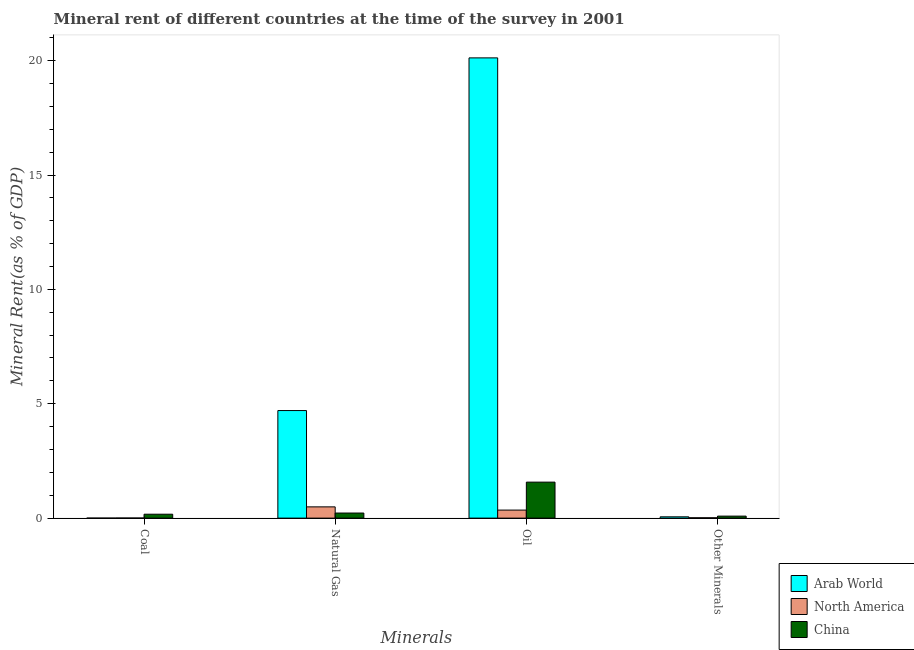How many different coloured bars are there?
Give a very brief answer. 3. How many groups of bars are there?
Your response must be concise. 4. Are the number of bars on each tick of the X-axis equal?
Ensure brevity in your answer.  Yes. How many bars are there on the 4th tick from the left?
Keep it short and to the point. 3. How many bars are there on the 4th tick from the right?
Your answer should be very brief. 3. What is the label of the 2nd group of bars from the left?
Offer a very short reply. Natural Gas. What is the  rent of other minerals in Arab World?
Provide a short and direct response. 0.06. Across all countries, what is the maximum natural gas rent?
Provide a short and direct response. 4.7. Across all countries, what is the minimum  rent of other minerals?
Offer a terse response. 0.01. In which country was the oil rent maximum?
Make the answer very short. Arab World. In which country was the coal rent minimum?
Give a very brief answer. Arab World. What is the total coal rent in the graph?
Provide a short and direct response. 0.17. What is the difference between the  rent of other minerals in North America and that in China?
Provide a succinct answer. -0.07. What is the difference between the natural gas rent in Arab World and the coal rent in North America?
Your answer should be very brief. 4.7. What is the average natural gas rent per country?
Provide a succinct answer. 1.81. What is the difference between the natural gas rent and oil rent in China?
Keep it short and to the point. -1.35. In how many countries, is the oil rent greater than 9 %?
Keep it short and to the point. 1. What is the ratio of the oil rent in China to that in North America?
Make the answer very short. 4.48. Is the  rent of other minerals in China less than that in North America?
Provide a succinct answer. No. What is the difference between the highest and the second highest natural gas rent?
Your answer should be compact. 4.21. What is the difference between the highest and the lowest  rent of other minerals?
Make the answer very short. 0.07. In how many countries, is the oil rent greater than the average oil rent taken over all countries?
Provide a short and direct response. 1. What does the 2nd bar from the left in Coal represents?
Make the answer very short. North America. What does the 3rd bar from the right in Oil represents?
Provide a succinct answer. Arab World. Is it the case that in every country, the sum of the coal rent and natural gas rent is greater than the oil rent?
Your response must be concise. No. What is the difference between two consecutive major ticks on the Y-axis?
Make the answer very short. 5. Does the graph contain grids?
Your answer should be compact. No. How many legend labels are there?
Your answer should be very brief. 3. How are the legend labels stacked?
Offer a very short reply. Vertical. What is the title of the graph?
Give a very brief answer. Mineral rent of different countries at the time of the survey in 2001. What is the label or title of the X-axis?
Make the answer very short. Minerals. What is the label or title of the Y-axis?
Make the answer very short. Mineral Rent(as % of GDP). What is the Mineral Rent(as % of GDP) of Arab World in Coal?
Your answer should be compact. 1.52442917434249e-7. What is the Mineral Rent(as % of GDP) in North America in Coal?
Your answer should be very brief. 0. What is the Mineral Rent(as % of GDP) in China in Coal?
Ensure brevity in your answer.  0.17. What is the Mineral Rent(as % of GDP) of Arab World in Natural Gas?
Offer a terse response. 4.7. What is the Mineral Rent(as % of GDP) in North America in Natural Gas?
Your answer should be very brief. 0.49. What is the Mineral Rent(as % of GDP) in China in Natural Gas?
Ensure brevity in your answer.  0.22. What is the Mineral Rent(as % of GDP) of Arab World in Oil?
Offer a terse response. 20.12. What is the Mineral Rent(as % of GDP) of North America in Oil?
Offer a terse response. 0.35. What is the Mineral Rent(as % of GDP) of China in Oil?
Provide a short and direct response. 1.57. What is the Mineral Rent(as % of GDP) in Arab World in Other Minerals?
Ensure brevity in your answer.  0.06. What is the Mineral Rent(as % of GDP) of North America in Other Minerals?
Provide a succinct answer. 0.01. What is the Mineral Rent(as % of GDP) in China in Other Minerals?
Keep it short and to the point. 0.09. Across all Minerals, what is the maximum Mineral Rent(as % of GDP) in Arab World?
Ensure brevity in your answer.  20.12. Across all Minerals, what is the maximum Mineral Rent(as % of GDP) in North America?
Your answer should be very brief. 0.49. Across all Minerals, what is the maximum Mineral Rent(as % of GDP) of China?
Your answer should be very brief. 1.57. Across all Minerals, what is the minimum Mineral Rent(as % of GDP) of Arab World?
Offer a terse response. 1.52442917434249e-7. Across all Minerals, what is the minimum Mineral Rent(as % of GDP) in North America?
Your answer should be compact. 0. Across all Minerals, what is the minimum Mineral Rent(as % of GDP) in China?
Your answer should be very brief. 0.09. What is the total Mineral Rent(as % of GDP) of Arab World in the graph?
Provide a short and direct response. 24.88. What is the total Mineral Rent(as % of GDP) in North America in the graph?
Offer a very short reply. 0.86. What is the total Mineral Rent(as % of GDP) in China in the graph?
Offer a very short reply. 2.05. What is the difference between the Mineral Rent(as % of GDP) of Arab World in Coal and that in Natural Gas?
Keep it short and to the point. -4.7. What is the difference between the Mineral Rent(as % of GDP) in North America in Coal and that in Natural Gas?
Keep it short and to the point. -0.49. What is the difference between the Mineral Rent(as % of GDP) in China in Coal and that in Natural Gas?
Provide a succinct answer. -0.05. What is the difference between the Mineral Rent(as % of GDP) of Arab World in Coal and that in Oil?
Your response must be concise. -20.12. What is the difference between the Mineral Rent(as % of GDP) of North America in Coal and that in Oil?
Provide a succinct answer. -0.35. What is the difference between the Mineral Rent(as % of GDP) in China in Coal and that in Oil?
Offer a terse response. -1.4. What is the difference between the Mineral Rent(as % of GDP) in Arab World in Coal and that in Other Minerals?
Make the answer very short. -0.06. What is the difference between the Mineral Rent(as % of GDP) in North America in Coal and that in Other Minerals?
Your answer should be very brief. -0.01. What is the difference between the Mineral Rent(as % of GDP) in China in Coal and that in Other Minerals?
Provide a short and direct response. 0.08. What is the difference between the Mineral Rent(as % of GDP) in Arab World in Natural Gas and that in Oil?
Provide a short and direct response. -15.42. What is the difference between the Mineral Rent(as % of GDP) of North America in Natural Gas and that in Oil?
Keep it short and to the point. 0.14. What is the difference between the Mineral Rent(as % of GDP) of China in Natural Gas and that in Oil?
Offer a very short reply. -1.35. What is the difference between the Mineral Rent(as % of GDP) in Arab World in Natural Gas and that in Other Minerals?
Give a very brief answer. 4.65. What is the difference between the Mineral Rent(as % of GDP) in North America in Natural Gas and that in Other Minerals?
Offer a very short reply. 0.48. What is the difference between the Mineral Rent(as % of GDP) in China in Natural Gas and that in Other Minerals?
Your answer should be compact. 0.14. What is the difference between the Mineral Rent(as % of GDP) of Arab World in Oil and that in Other Minerals?
Your answer should be compact. 20.06. What is the difference between the Mineral Rent(as % of GDP) of North America in Oil and that in Other Minerals?
Provide a succinct answer. 0.34. What is the difference between the Mineral Rent(as % of GDP) in China in Oil and that in Other Minerals?
Provide a succinct answer. 1.49. What is the difference between the Mineral Rent(as % of GDP) of Arab World in Coal and the Mineral Rent(as % of GDP) of North America in Natural Gas?
Your answer should be very brief. -0.49. What is the difference between the Mineral Rent(as % of GDP) in Arab World in Coal and the Mineral Rent(as % of GDP) in China in Natural Gas?
Provide a short and direct response. -0.22. What is the difference between the Mineral Rent(as % of GDP) in North America in Coal and the Mineral Rent(as % of GDP) in China in Natural Gas?
Offer a terse response. -0.22. What is the difference between the Mineral Rent(as % of GDP) in Arab World in Coal and the Mineral Rent(as % of GDP) in North America in Oil?
Make the answer very short. -0.35. What is the difference between the Mineral Rent(as % of GDP) in Arab World in Coal and the Mineral Rent(as % of GDP) in China in Oil?
Ensure brevity in your answer.  -1.57. What is the difference between the Mineral Rent(as % of GDP) in North America in Coal and the Mineral Rent(as % of GDP) in China in Oil?
Give a very brief answer. -1.57. What is the difference between the Mineral Rent(as % of GDP) in Arab World in Coal and the Mineral Rent(as % of GDP) in North America in Other Minerals?
Keep it short and to the point. -0.01. What is the difference between the Mineral Rent(as % of GDP) in Arab World in Coal and the Mineral Rent(as % of GDP) in China in Other Minerals?
Your answer should be very brief. -0.09. What is the difference between the Mineral Rent(as % of GDP) in North America in Coal and the Mineral Rent(as % of GDP) in China in Other Minerals?
Give a very brief answer. -0.08. What is the difference between the Mineral Rent(as % of GDP) in Arab World in Natural Gas and the Mineral Rent(as % of GDP) in North America in Oil?
Give a very brief answer. 4.35. What is the difference between the Mineral Rent(as % of GDP) of Arab World in Natural Gas and the Mineral Rent(as % of GDP) of China in Oil?
Provide a short and direct response. 3.13. What is the difference between the Mineral Rent(as % of GDP) in North America in Natural Gas and the Mineral Rent(as % of GDP) in China in Oil?
Your answer should be very brief. -1.08. What is the difference between the Mineral Rent(as % of GDP) of Arab World in Natural Gas and the Mineral Rent(as % of GDP) of North America in Other Minerals?
Make the answer very short. 4.69. What is the difference between the Mineral Rent(as % of GDP) of Arab World in Natural Gas and the Mineral Rent(as % of GDP) of China in Other Minerals?
Offer a terse response. 4.62. What is the difference between the Mineral Rent(as % of GDP) in North America in Natural Gas and the Mineral Rent(as % of GDP) in China in Other Minerals?
Your answer should be very brief. 0.4. What is the difference between the Mineral Rent(as % of GDP) in Arab World in Oil and the Mineral Rent(as % of GDP) in North America in Other Minerals?
Offer a terse response. 20.11. What is the difference between the Mineral Rent(as % of GDP) of Arab World in Oil and the Mineral Rent(as % of GDP) of China in Other Minerals?
Your answer should be compact. 20.03. What is the difference between the Mineral Rent(as % of GDP) in North America in Oil and the Mineral Rent(as % of GDP) in China in Other Minerals?
Provide a succinct answer. 0.26. What is the average Mineral Rent(as % of GDP) of Arab World per Minerals?
Ensure brevity in your answer.  6.22. What is the average Mineral Rent(as % of GDP) of North America per Minerals?
Your answer should be compact. 0.22. What is the average Mineral Rent(as % of GDP) in China per Minerals?
Your answer should be very brief. 0.51. What is the difference between the Mineral Rent(as % of GDP) in Arab World and Mineral Rent(as % of GDP) in North America in Coal?
Offer a very short reply. -0. What is the difference between the Mineral Rent(as % of GDP) in Arab World and Mineral Rent(as % of GDP) in China in Coal?
Your answer should be compact. -0.17. What is the difference between the Mineral Rent(as % of GDP) in North America and Mineral Rent(as % of GDP) in China in Coal?
Provide a succinct answer. -0.17. What is the difference between the Mineral Rent(as % of GDP) in Arab World and Mineral Rent(as % of GDP) in North America in Natural Gas?
Offer a very short reply. 4.21. What is the difference between the Mineral Rent(as % of GDP) in Arab World and Mineral Rent(as % of GDP) in China in Natural Gas?
Your answer should be very brief. 4.48. What is the difference between the Mineral Rent(as % of GDP) of North America and Mineral Rent(as % of GDP) of China in Natural Gas?
Provide a succinct answer. 0.27. What is the difference between the Mineral Rent(as % of GDP) of Arab World and Mineral Rent(as % of GDP) of North America in Oil?
Your answer should be compact. 19.77. What is the difference between the Mineral Rent(as % of GDP) of Arab World and Mineral Rent(as % of GDP) of China in Oil?
Your response must be concise. 18.55. What is the difference between the Mineral Rent(as % of GDP) of North America and Mineral Rent(as % of GDP) of China in Oil?
Keep it short and to the point. -1.22. What is the difference between the Mineral Rent(as % of GDP) in Arab World and Mineral Rent(as % of GDP) in North America in Other Minerals?
Your response must be concise. 0.04. What is the difference between the Mineral Rent(as % of GDP) in Arab World and Mineral Rent(as % of GDP) in China in Other Minerals?
Offer a terse response. -0.03. What is the difference between the Mineral Rent(as % of GDP) in North America and Mineral Rent(as % of GDP) in China in Other Minerals?
Offer a very short reply. -0.07. What is the ratio of the Mineral Rent(as % of GDP) in North America in Coal to that in Natural Gas?
Your answer should be compact. 0.01. What is the ratio of the Mineral Rent(as % of GDP) of China in Coal to that in Natural Gas?
Your answer should be very brief. 0.77. What is the ratio of the Mineral Rent(as % of GDP) in Arab World in Coal to that in Oil?
Your answer should be compact. 0. What is the ratio of the Mineral Rent(as % of GDP) of North America in Coal to that in Oil?
Your answer should be very brief. 0.01. What is the ratio of the Mineral Rent(as % of GDP) in China in Coal to that in Oil?
Your response must be concise. 0.11. What is the ratio of the Mineral Rent(as % of GDP) in Arab World in Coal to that in Other Minerals?
Your answer should be very brief. 0. What is the ratio of the Mineral Rent(as % of GDP) of North America in Coal to that in Other Minerals?
Your answer should be very brief. 0.24. What is the ratio of the Mineral Rent(as % of GDP) in China in Coal to that in Other Minerals?
Ensure brevity in your answer.  1.95. What is the ratio of the Mineral Rent(as % of GDP) in Arab World in Natural Gas to that in Oil?
Provide a short and direct response. 0.23. What is the ratio of the Mineral Rent(as % of GDP) in North America in Natural Gas to that in Oil?
Ensure brevity in your answer.  1.4. What is the ratio of the Mineral Rent(as % of GDP) of China in Natural Gas to that in Oil?
Offer a very short reply. 0.14. What is the ratio of the Mineral Rent(as % of GDP) in Arab World in Natural Gas to that in Other Minerals?
Give a very brief answer. 83.38. What is the ratio of the Mineral Rent(as % of GDP) of North America in Natural Gas to that in Other Minerals?
Provide a succinct answer. 33.23. What is the ratio of the Mineral Rent(as % of GDP) of China in Natural Gas to that in Other Minerals?
Make the answer very short. 2.55. What is the ratio of the Mineral Rent(as % of GDP) in Arab World in Oil to that in Other Minerals?
Offer a terse response. 356.72. What is the ratio of the Mineral Rent(as % of GDP) in North America in Oil to that in Other Minerals?
Make the answer very short. 23.7. What is the ratio of the Mineral Rent(as % of GDP) of China in Oil to that in Other Minerals?
Keep it short and to the point. 18.02. What is the difference between the highest and the second highest Mineral Rent(as % of GDP) of Arab World?
Offer a very short reply. 15.42. What is the difference between the highest and the second highest Mineral Rent(as % of GDP) of North America?
Give a very brief answer. 0.14. What is the difference between the highest and the second highest Mineral Rent(as % of GDP) in China?
Ensure brevity in your answer.  1.35. What is the difference between the highest and the lowest Mineral Rent(as % of GDP) of Arab World?
Your answer should be very brief. 20.12. What is the difference between the highest and the lowest Mineral Rent(as % of GDP) in North America?
Provide a short and direct response. 0.49. What is the difference between the highest and the lowest Mineral Rent(as % of GDP) in China?
Keep it short and to the point. 1.49. 